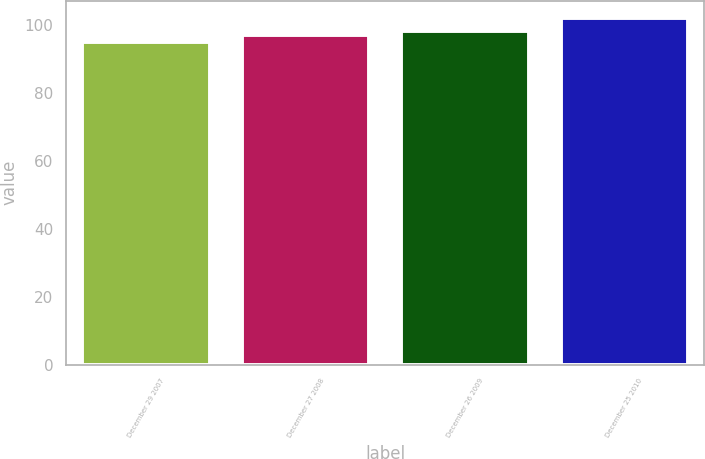Convert chart. <chart><loc_0><loc_0><loc_500><loc_500><bar_chart><fcel>December 29 2007<fcel>December 27 2008<fcel>December 26 2009<fcel>December 25 2010<nl><fcel>95<fcel>97<fcel>98<fcel>102<nl></chart> 